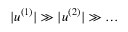<formula> <loc_0><loc_0><loc_500><loc_500>| u ^ { ( 1 ) } | \gg | u ^ { ( 2 ) } | \gg \dots</formula> 